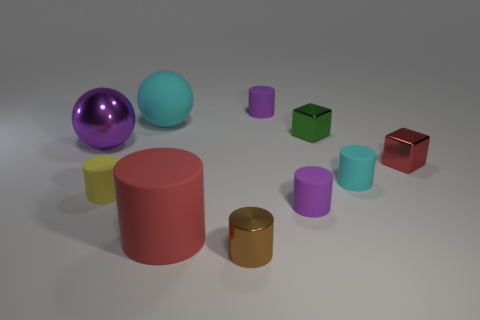What can you infer about the lighting conditions in the room where these objects are located? The lighting in the room seems to be soft and diffused, with shadows indicating that the light source is not directly overhead but positioned at an angle. The gentle shadowing and lack of harsh highlights suggest an environment with controlled lighting suitable for showcasing the objects without causing glare. 